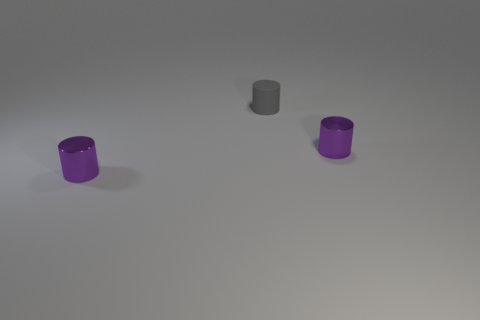Add 1 tiny gray rubber things. How many objects exist? 4 Add 3 yellow metal things. How many yellow metal things exist? 3 Subtract 0 green spheres. How many objects are left? 3 Subtract all tiny objects. Subtract all big gray shiny balls. How many objects are left? 0 Add 2 small metallic objects. How many small metallic objects are left? 4 